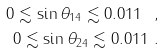Convert formula to latex. <formula><loc_0><loc_0><loc_500><loc_500>0 \lesssim \sin \theta _ { 1 4 } \lesssim 0 . 0 1 1 \ , \\ 0 \lesssim \sin \theta _ { 2 4 } \lesssim 0 . 0 1 1 \ .</formula> 